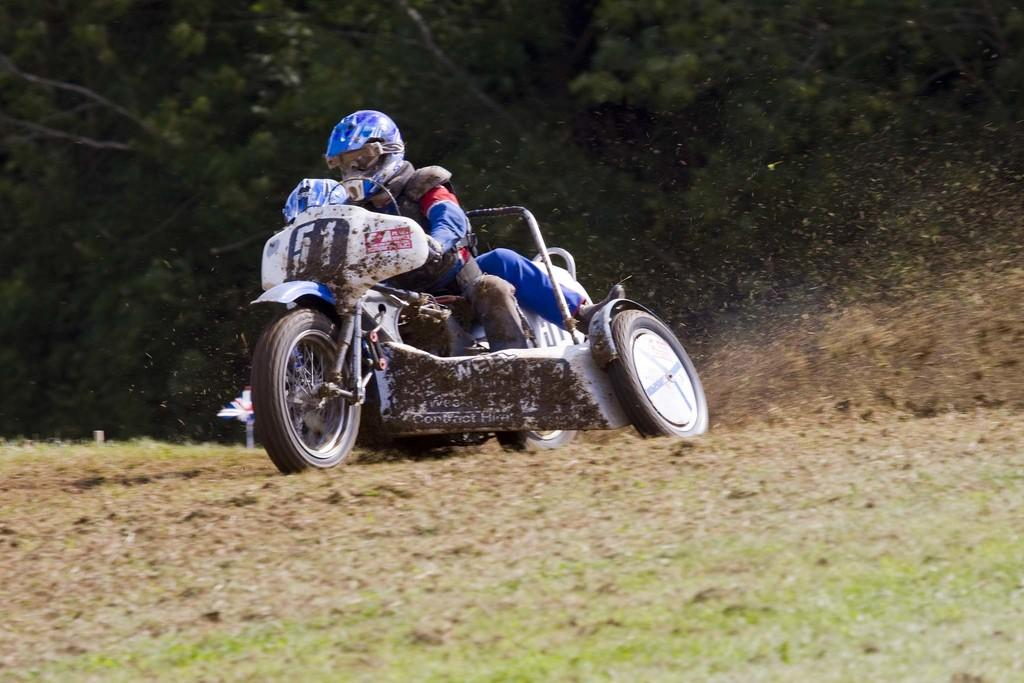Who is present in the image? There is a person in the image. What is the person wearing? The person is wearing a helmet. What is the person doing in the image? The person is riding a vehicle. Where is the vehicle located? The vehicle is on the ground. What can be seen in the background of the image? There are trees in the background of the image. What type of soap is the person using to clean the vehicle in the image? There is no soap present in the image, and the person is not cleaning the vehicle. 